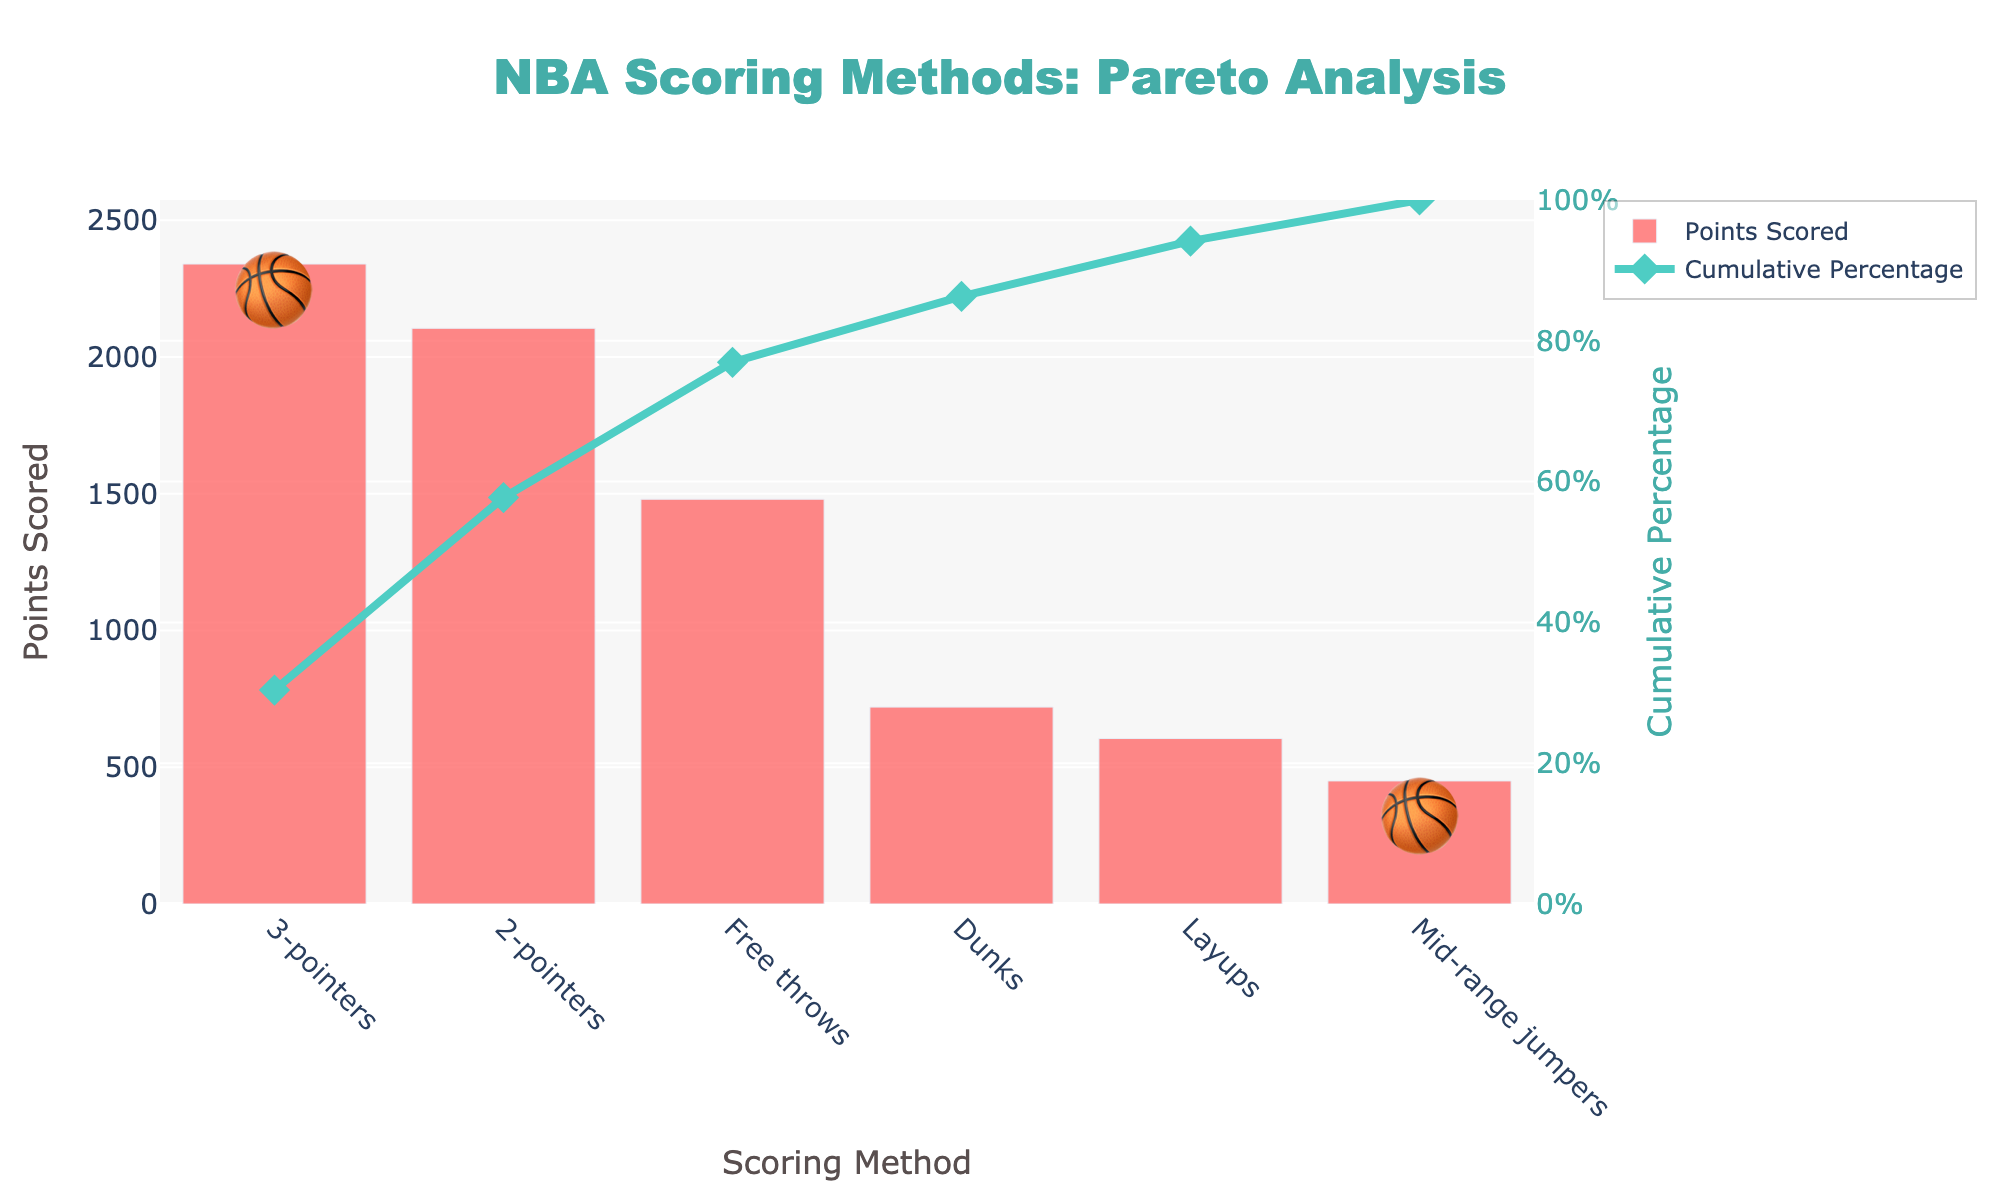What is the title of the chart? The title of the chart is located at the top of the figure. It is designed to provide a quick understanding of the chart's content by summarizing it concisely.
Answer: NBA Scoring Methods: Pareto Analysis How many scoring methods are represented in the chart? The number of scoring methods can be counted by looking at the x-axis where each method is listed.
Answer: 6 Which scoring method scored the highest points? The bar representing the scoring method with the highest points is the tallest one.
Answer: 3-pointers What is the cumulative percentage reached by the 3-pointers and 2-pointers combined? From the chart, identify the cumulative percentage for 2-pointers and add it to the cumulative percentage only due to 3-pointers (since it precedes 2-pointers).
Answer: 57.30% How do the points scored by dunks compare with those scored by free throws? Compare the heights of the bars corresponding to dunks and free throws to see which is greater.
Answer: Free throws score more points What is the cumulative percentage after including layups? Look at the cumulative percentage line where the layups end and note the value.
Answer: 87.28% Which scoring method has the lowest cumulative percentage before it is added? Determine the smallest scoring method by cumulative percentage by looking at the smallest value in the line chart before that value is compounded.
Answer: Mid-range jumpers What is the total points scored by 2-pointers and layups combined? Add the points scored by 2-pointers and layups. 2105 + 605 = 2710
Answer: 2710 What scoring methods together account for more than 80% of the total points? Identify the point where the cumulative percentage line crosses the 80% mark and check which scoring methods are included up to that point.
Answer: 3-pointers, 2-pointers, Free throws, Dunks By how many points do mid-range jumpers score less compared to dunks? Subtract the points scored by mid-range jumpers from the points scored by dunks, i.e., 720 - 450 = 270.
Answer: 270 